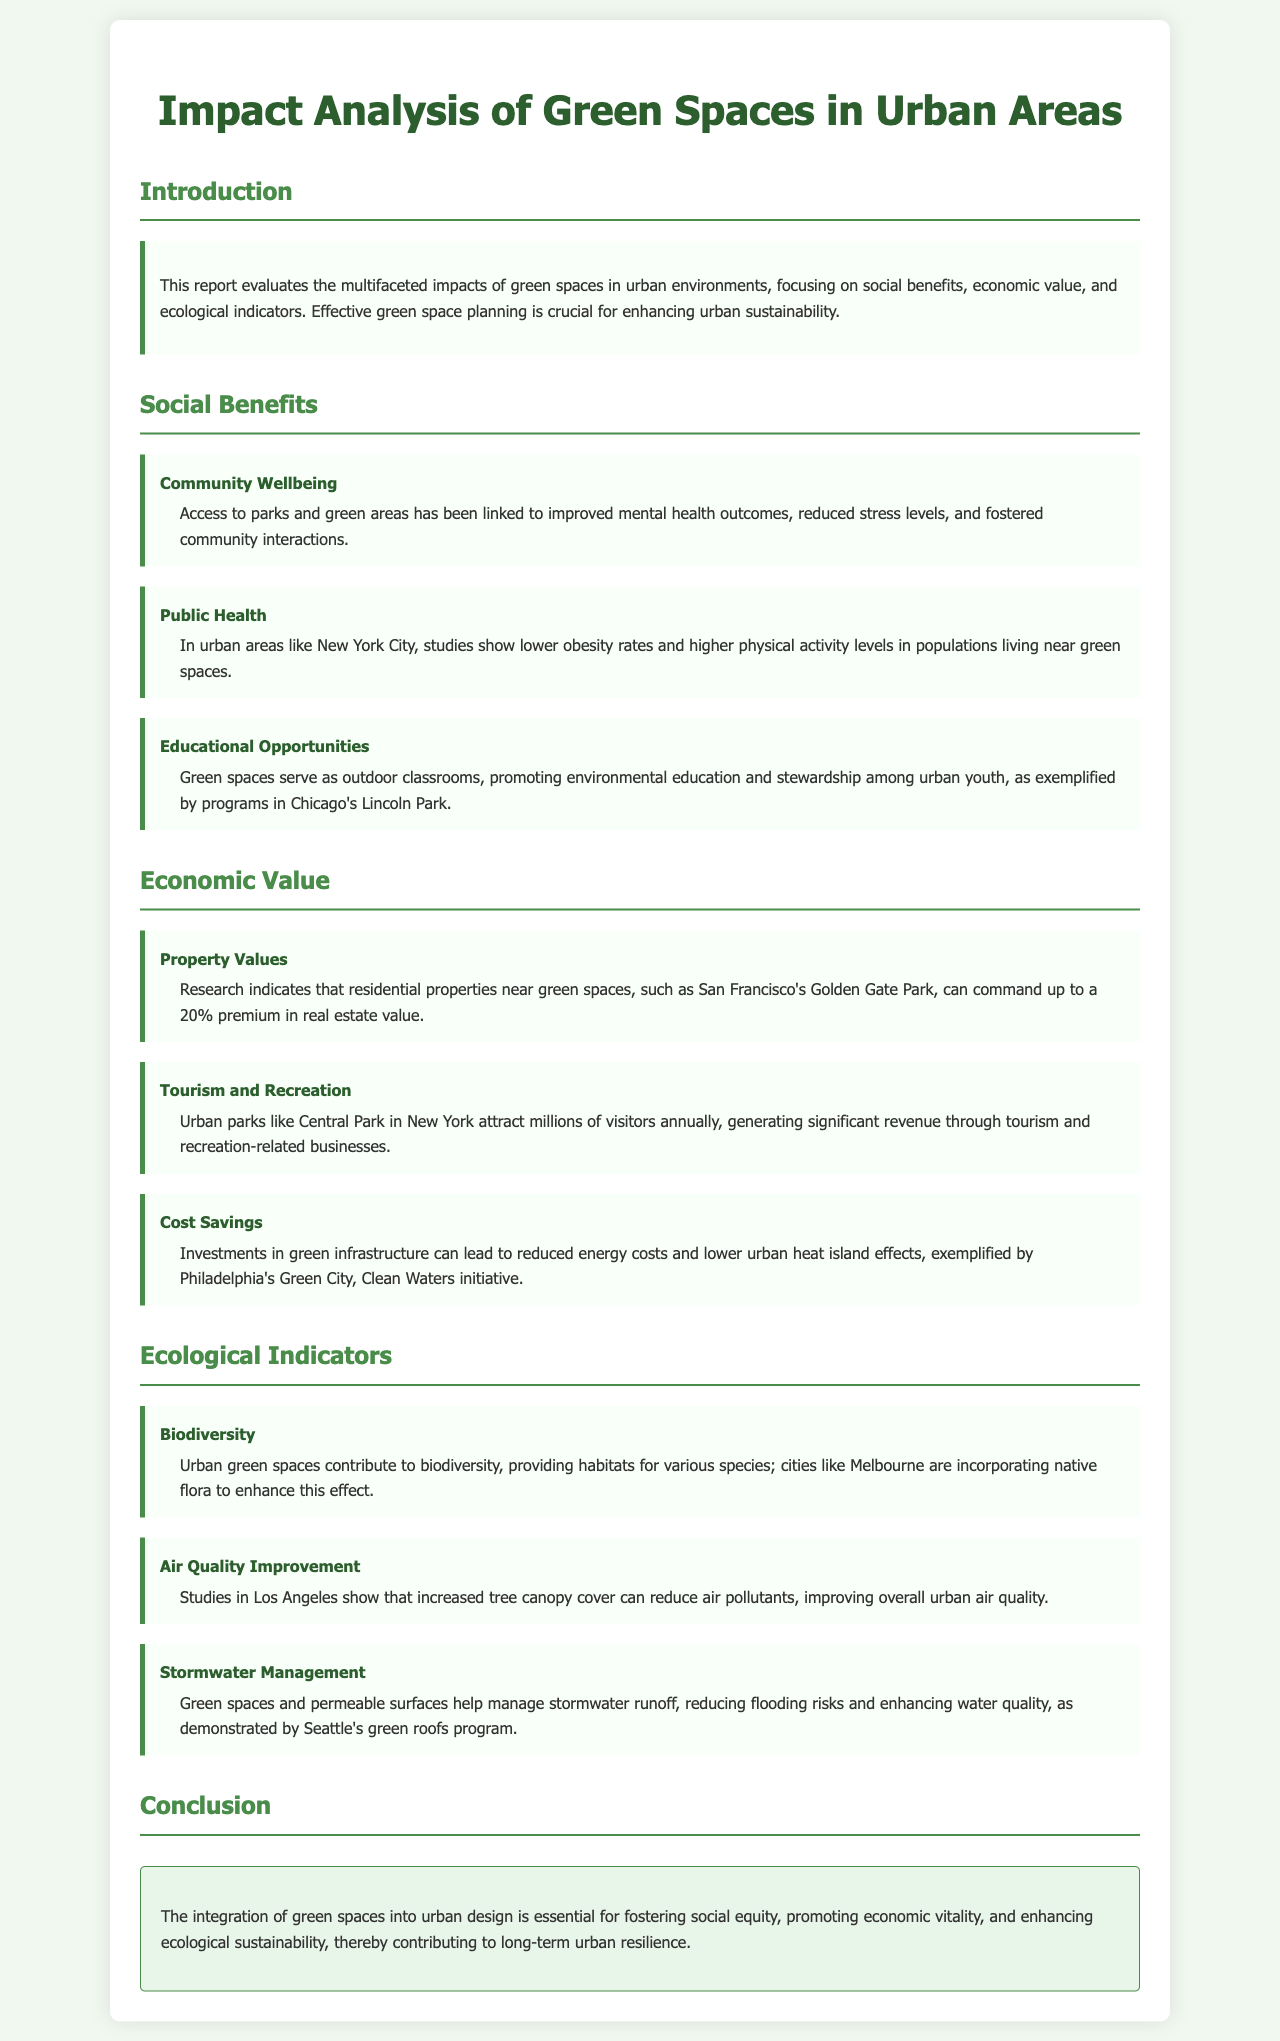What is the main focus of the report? The report evaluates the impacts of green spaces in urban environments, specifically focusing on social benefits, economic value, and ecological indicators.
Answer: Impacts of green spaces What percentage premium can residential properties near green spaces command? The report states that residential properties near green spaces can command up to a 20% premium in real estate value.
Answer: 20% Which city is cited for showing lower obesity rates linked to green spaces? The document mentions New York City as having lower obesity rates in populations living near green spaces.
Answer: New York City What program in Chicago promotes environmental education? The educational opportunities provided by green spaces in Chicago are exemplified by programs in Lincoln Park.
Answer: Lincoln Park What ecological benefit is associated with increased tree canopy cover? The report states that increased tree canopy cover can reduce air pollutants, improving overall urban air quality.
Answer: Air quality improvement What green initiative is highlighted in Philadelphia? The Green City, Clean Waters initiative is specifically mentioned in relation to cost savings from green infrastructure investments.
Answer: Green City, Clean Waters Which urban phenomenon is reduced by permeable surfaces in green spaces? The document indicates that permeable surfaces help manage stormwater runoff, reducing flooding risks.
Answer: Flooding risks How do green spaces enhance community interactions? Access to parks and green areas has been linked to improved mental health outcomes and fostered community interactions.
Answer: Improved mental health outcomes What do urban parks contribute to in terms of tourism? Urban parks, like Central Park, attract millions of visitors annually, generating significant revenue through tourism.
Answer: Significant revenue 